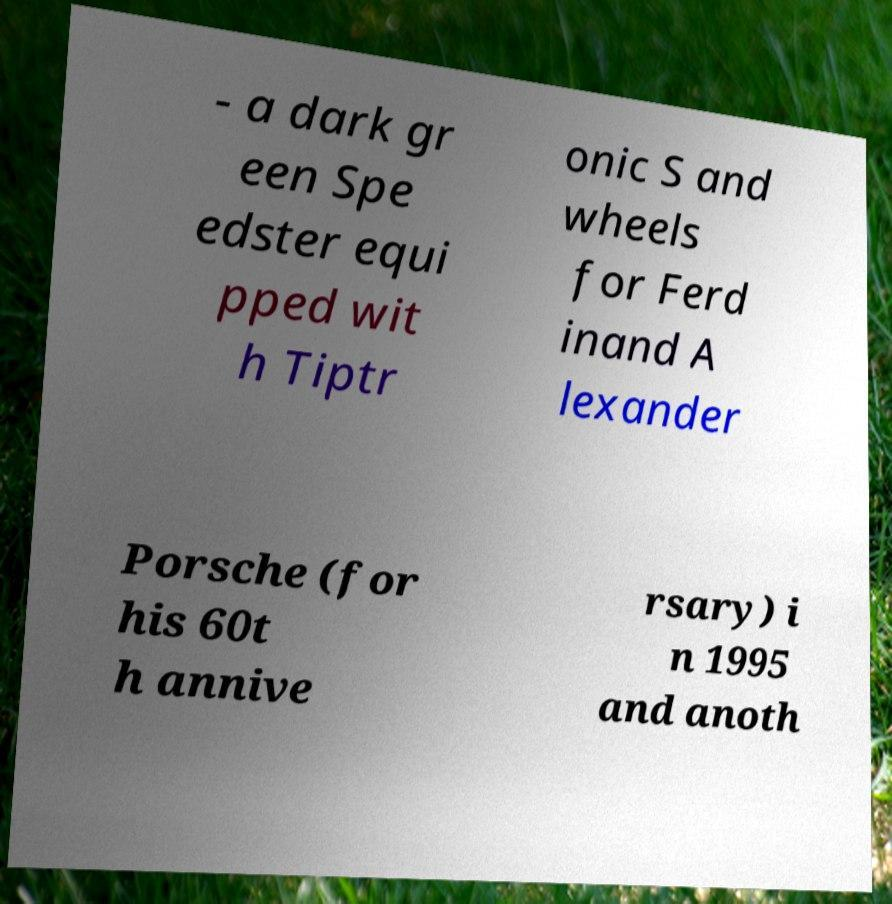There's text embedded in this image that I need extracted. Can you transcribe it verbatim? - a dark gr een Spe edster equi pped wit h Tiptr onic S and wheels for Ferd inand A lexander Porsche (for his 60t h annive rsary) i n 1995 and anoth 